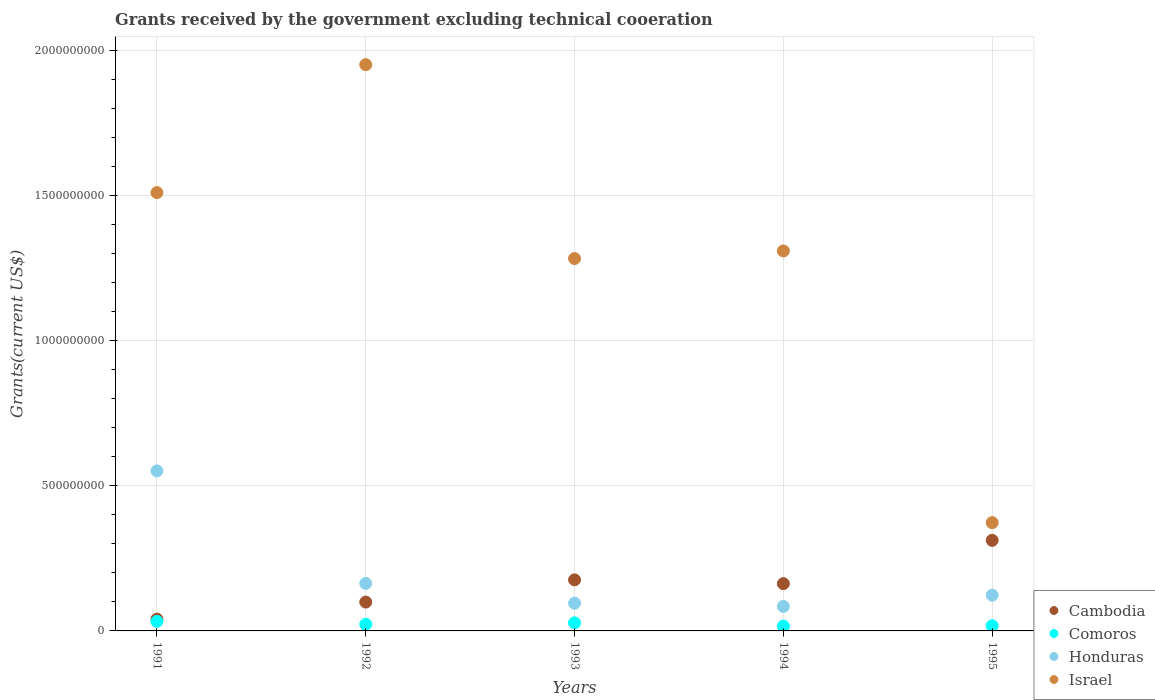How many different coloured dotlines are there?
Provide a succinct answer. 4. Is the number of dotlines equal to the number of legend labels?
Give a very brief answer. Yes. What is the total grants received by the government in Comoros in 1992?
Keep it short and to the point. 2.28e+07. Across all years, what is the maximum total grants received by the government in Honduras?
Keep it short and to the point. 5.52e+08. Across all years, what is the minimum total grants received by the government in Israel?
Keep it short and to the point. 3.73e+08. In which year was the total grants received by the government in Honduras minimum?
Offer a very short reply. 1994. What is the total total grants received by the government in Cambodia in the graph?
Give a very brief answer. 7.91e+08. What is the difference between the total grants received by the government in Honduras in 1992 and that in 1993?
Offer a terse response. 6.81e+07. What is the difference between the total grants received by the government in Cambodia in 1992 and the total grants received by the government in Honduras in 1995?
Offer a terse response. -2.38e+07. What is the average total grants received by the government in Israel per year?
Make the answer very short. 1.29e+09. In the year 1991, what is the difference between the total grants received by the government in Comoros and total grants received by the government in Cambodia?
Keep it short and to the point. -7.92e+06. In how many years, is the total grants received by the government in Cambodia greater than 1100000000 US$?
Offer a very short reply. 0. What is the ratio of the total grants received by the government in Comoros in 1991 to that in 1994?
Provide a succinct answer. 1.99. What is the difference between the highest and the second highest total grants received by the government in Honduras?
Your response must be concise. 3.88e+08. What is the difference between the highest and the lowest total grants received by the government in Cambodia?
Keep it short and to the point. 2.72e+08. Is it the case that in every year, the sum of the total grants received by the government in Honduras and total grants received by the government in Comoros  is greater than the total grants received by the government in Cambodia?
Give a very brief answer. No. Does the total grants received by the government in Israel monotonically increase over the years?
Ensure brevity in your answer.  No. Is the total grants received by the government in Honduras strictly greater than the total grants received by the government in Cambodia over the years?
Ensure brevity in your answer.  No. Is the total grants received by the government in Israel strictly less than the total grants received by the government in Honduras over the years?
Offer a terse response. No. How many dotlines are there?
Ensure brevity in your answer.  4. What is the difference between two consecutive major ticks on the Y-axis?
Your response must be concise. 5.00e+08. Where does the legend appear in the graph?
Give a very brief answer. Bottom right. How are the legend labels stacked?
Give a very brief answer. Vertical. What is the title of the graph?
Provide a short and direct response. Grants received by the government excluding technical cooeration. Does "Azerbaijan" appear as one of the legend labels in the graph?
Provide a succinct answer. No. What is the label or title of the X-axis?
Your answer should be very brief. Years. What is the label or title of the Y-axis?
Provide a succinct answer. Grants(current US$). What is the Grants(current US$) of Cambodia in 1991?
Make the answer very short. 4.07e+07. What is the Grants(current US$) in Comoros in 1991?
Provide a succinct answer. 3.28e+07. What is the Grants(current US$) in Honduras in 1991?
Your answer should be very brief. 5.52e+08. What is the Grants(current US$) in Israel in 1991?
Provide a short and direct response. 1.51e+09. What is the Grants(current US$) in Cambodia in 1992?
Ensure brevity in your answer.  9.94e+07. What is the Grants(current US$) of Comoros in 1992?
Your response must be concise. 2.28e+07. What is the Grants(current US$) of Honduras in 1992?
Your response must be concise. 1.64e+08. What is the Grants(current US$) of Israel in 1992?
Make the answer very short. 1.95e+09. What is the Grants(current US$) in Cambodia in 1993?
Your response must be concise. 1.76e+08. What is the Grants(current US$) in Comoros in 1993?
Provide a short and direct response. 2.78e+07. What is the Grants(current US$) of Honduras in 1993?
Make the answer very short. 9.57e+07. What is the Grants(current US$) in Israel in 1993?
Offer a very short reply. 1.28e+09. What is the Grants(current US$) of Cambodia in 1994?
Offer a terse response. 1.63e+08. What is the Grants(current US$) of Comoros in 1994?
Your answer should be very brief. 1.65e+07. What is the Grants(current US$) in Honduras in 1994?
Make the answer very short. 8.44e+07. What is the Grants(current US$) of Israel in 1994?
Your response must be concise. 1.31e+09. What is the Grants(current US$) in Cambodia in 1995?
Ensure brevity in your answer.  3.12e+08. What is the Grants(current US$) of Comoros in 1995?
Give a very brief answer. 1.78e+07. What is the Grants(current US$) of Honduras in 1995?
Offer a terse response. 1.23e+08. What is the Grants(current US$) in Israel in 1995?
Provide a succinct answer. 3.73e+08. Across all years, what is the maximum Grants(current US$) of Cambodia?
Make the answer very short. 3.12e+08. Across all years, what is the maximum Grants(current US$) in Comoros?
Offer a very short reply. 3.28e+07. Across all years, what is the maximum Grants(current US$) of Honduras?
Provide a succinct answer. 5.52e+08. Across all years, what is the maximum Grants(current US$) in Israel?
Keep it short and to the point. 1.95e+09. Across all years, what is the minimum Grants(current US$) of Cambodia?
Your response must be concise. 4.07e+07. Across all years, what is the minimum Grants(current US$) of Comoros?
Provide a succinct answer. 1.65e+07. Across all years, what is the minimum Grants(current US$) of Honduras?
Make the answer very short. 8.44e+07. Across all years, what is the minimum Grants(current US$) in Israel?
Ensure brevity in your answer.  3.73e+08. What is the total Grants(current US$) of Cambodia in the graph?
Ensure brevity in your answer.  7.91e+08. What is the total Grants(current US$) in Comoros in the graph?
Your response must be concise. 1.18e+08. What is the total Grants(current US$) of Honduras in the graph?
Keep it short and to the point. 1.02e+09. What is the total Grants(current US$) of Israel in the graph?
Provide a succinct answer. 6.43e+09. What is the difference between the Grants(current US$) of Cambodia in 1991 and that in 1992?
Ensure brevity in your answer.  -5.87e+07. What is the difference between the Grants(current US$) in Comoros in 1991 and that in 1992?
Your answer should be very brief. 9.98e+06. What is the difference between the Grants(current US$) in Honduras in 1991 and that in 1992?
Give a very brief answer. 3.88e+08. What is the difference between the Grants(current US$) in Israel in 1991 and that in 1992?
Your answer should be compact. -4.41e+08. What is the difference between the Grants(current US$) of Cambodia in 1991 and that in 1993?
Your answer should be compact. -1.35e+08. What is the difference between the Grants(current US$) in Comoros in 1991 and that in 1993?
Your answer should be very brief. 4.96e+06. What is the difference between the Grants(current US$) in Honduras in 1991 and that in 1993?
Make the answer very short. 4.56e+08. What is the difference between the Grants(current US$) in Israel in 1991 and that in 1993?
Your answer should be very brief. 2.27e+08. What is the difference between the Grants(current US$) in Cambodia in 1991 and that in 1994?
Your response must be concise. -1.22e+08. What is the difference between the Grants(current US$) in Comoros in 1991 and that in 1994?
Offer a terse response. 1.63e+07. What is the difference between the Grants(current US$) of Honduras in 1991 and that in 1994?
Ensure brevity in your answer.  4.67e+08. What is the difference between the Grants(current US$) of Israel in 1991 and that in 1994?
Your answer should be very brief. 2.01e+08. What is the difference between the Grants(current US$) of Cambodia in 1991 and that in 1995?
Keep it short and to the point. -2.72e+08. What is the difference between the Grants(current US$) of Comoros in 1991 and that in 1995?
Offer a terse response. 1.50e+07. What is the difference between the Grants(current US$) of Honduras in 1991 and that in 1995?
Make the answer very short. 4.28e+08. What is the difference between the Grants(current US$) of Israel in 1991 and that in 1995?
Give a very brief answer. 1.14e+09. What is the difference between the Grants(current US$) in Cambodia in 1992 and that in 1993?
Your response must be concise. -7.66e+07. What is the difference between the Grants(current US$) in Comoros in 1992 and that in 1993?
Provide a succinct answer. -5.02e+06. What is the difference between the Grants(current US$) of Honduras in 1992 and that in 1993?
Your answer should be compact. 6.81e+07. What is the difference between the Grants(current US$) in Israel in 1992 and that in 1993?
Ensure brevity in your answer.  6.68e+08. What is the difference between the Grants(current US$) of Cambodia in 1992 and that in 1994?
Your answer should be compact. -6.36e+07. What is the difference between the Grants(current US$) of Comoros in 1992 and that in 1994?
Keep it short and to the point. 6.30e+06. What is the difference between the Grants(current US$) in Honduras in 1992 and that in 1994?
Provide a short and direct response. 7.93e+07. What is the difference between the Grants(current US$) in Israel in 1992 and that in 1994?
Your answer should be compact. 6.42e+08. What is the difference between the Grants(current US$) of Cambodia in 1992 and that in 1995?
Offer a terse response. -2.13e+08. What is the difference between the Grants(current US$) in Comoros in 1992 and that in 1995?
Offer a very short reply. 5.06e+06. What is the difference between the Grants(current US$) of Honduras in 1992 and that in 1995?
Provide a short and direct response. 4.06e+07. What is the difference between the Grants(current US$) in Israel in 1992 and that in 1995?
Keep it short and to the point. 1.58e+09. What is the difference between the Grants(current US$) in Cambodia in 1993 and that in 1994?
Give a very brief answer. 1.30e+07. What is the difference between the Grants(current US$) of Comoros in 1993 and that in 1994?
Provide a short and direct response. 1.13e+07. What is the difference between the Grants(current US$) in Honduras in 1993 and that in 1994?
Your answer should be compact. 1.12e+07. What is the difference between the Grants(current US$) of Israel in 1993 and that in 1994?
Offer a very short reply. -2.63e+07. What is the difference between the Grants(current US$) of Cambodia in 1993 and that in 1995?
Ensure brevity in your answer.  -1.36e+08. What is the difference between the Grants(current US$) of Comoros in 1993 and that in 1995?
Keep it short and to the point. 1.01e+07. What is the difference between the Grants(current US$) of Honduras in 1993 and that in 1995?
Ensure brevity in your answer.  -2.75e+07. What is the difference between the Grants(current US$) in Israel in 1993 and that in 1995?
Give a very brief answer. 9.10e+08. What is the difference between the Grants(current US$) of Cambodia in 1994 and that in 1995?
Your answer should be compact. -1.49e+08. What is the difference between the Grants(current US$) of Comoros in 1994 and that in 1995?
Your answer should be compact. -1.24e+06. What is the difference between the Grants(current US$) of Honduras in 1994 and that in 1995?
Keep it short and to the point. -3.88e+07. What is the difference between the Grants(current US$) of Israel in 1994 and that in 1995?
Your answer should be compact. 9.37e+08. What is the difference between the Grants(current US$) in Cambodia in 1991 and the Grants(current US$) in Comoros in 1992?
Your response must be concise. 1.79e+07. What is the difference between the Grants(current US$) of Cambodia in 1991 and the Grants(current US$) of Honduras in 1992?
Give a very brief answer. -1.23e+08. What is the difference between the Grants(current US$) of Cambodia in 1991 and the Grants(current US$) of Israel in 1992?
Provide a succinct answer. -1.91e+09. What is the difference between the Grants(current US$) in Comoros in 1991 and the Grants(current US$) in Honduras in 1992?
Your answer should be very brief. -1.31e+08. What is the difference between the Grants(current US$) of Comoros in 1991 and the Grants(current US$) of Israel in 1992?
Your answer should be compact. -1.92e+09. What is the difference between the Grants(current US$) of Honduras in 1991 and the Grants(current US$) of Israel in 1992?
Your response must be concise. -1.40e+09. What is the difference between the Grants(current US$) in Cambodia in 1991 and the Grants(current US$) in Comoros in 1993?
Provide a succinct answer. 1.29e+07. What is the difference between the Grants(current US$) in Cambodia in 1991 and the Grants(current US$) in Honduras in 1993?
Make the answer very short. -5.50e+07. What is the difference between the Grants(current US$) of Cambodia in 1991 and the Grants(current US$) of Israel in 1993?
Ensure brevity in your answer.  -1.24e+09. What is the difference between the Grants(current US$) in Comoros in 1991 and the Grants(current US$) in Honduras in 1993?
Your response must be concise. -6.29e+07. What is the difference between the Grants(current US$) in Comoros in 1991 and the Grants(current US$) in Israel in 1993?
Your answer should be very brief. -1.25e+09. What is the difference between the Grants(current US$) in Honduras in 1991 and the Grants(current US$) in Israel in 1993?
Give a very brief answer. -7.32e+08. What is the difference between the Grants(current US$) of Cambodia in 1991 and the Grants(current US$) of Comoros in 1994?
Your response must be concise. 2.42e+07. What is the difference between the Grants(current US$) of Cambodia in 1991 and the Grants(current US$) of Honduras in 1994?
Your response must be concise. -4.37e+07. What is the difference between the Grants(current US$) in Cambodia in 1991 and the Grants(current US$) in Israel in 1994?
Make the answer very short. -1.27e+09. What is the difference between the Grants(current US$) in Comoros in 1991 and the Grants(current US$) in Honduras in 1994?
Offer a terse response. -5.16e+07. What is the difference between the Grants(current US$) of Comoros in 1991 and the Grants(current US$) of Israel in 1994?
Give a very brief answer. -1.28e+09. What is the difference between the Grants(current US$) in Honduras in 1991 and the Grants(current US$) in Israel in 1994?
Give a very brief answer. -7.58e+08. What is the difference between the Grants(current US$) in Cambodia in 1991 and the Grants(current US$) in Comoros in 1995?
Give a very brief answer. 2.30e+07. What is the difference between the Grants(current US$) in Cambodia in 1991 and the Grants(current US$) in Honduras in 1995?
Ensure brevity in your answer.  -8.25e+07. What is the difference between the Grants(current US$) in Cambodia in 1991 and the Grants(current US$) in Israel in 1995?
Provide a short and direct response. -3.33e+08. What is the difference between the Grants(current US$) of Comoros in 1991 and the Grants(current US$) of Honduras in 1995?
Keep it short and to the point. -9.04e+07. What is the difference between the Grants(current US$) of Comoros in 1991 and the Grants(current US$) of Israel in 1995?
Your answer should be very brief. -3.41e+08. What is the difference between the Grants(current US$) in Honduras in 1991 and the Grants(current US$) in Israel in 1995?
Make the answer very short. 1.78e+08. What is the difference between the Grants(current US$) of Cambodia in 1992 and the Grants(current US$) of Comoros in 1993?
Your answer should be very brief. 7.16e+07. What is the difference between the Grants(current US$) in Cambodia in 1992 and the Grants(current US$) in Honduras in 1993?
Your answer should be very brief. 3.73e+06. What is the difference between the Grants(current US$) of Cambodia in 1992 and the Grants(current US$) of Israel in 1993?
Your answer should be very brief. -1.18e+09. What is the difference between the Grants(current US$) in Comoros in 1992 and the Grants(current US$) in Honduras in 1993?
Offer a very short reply. -7.29e+07. What is the difference between the Grants(current US$) of Comoros in 1992 and the Grants(current US$) of Israel in 1993?
Provide a short and direct response. -1.26e+09. What is the difference between the Grants(current US$) in Honduras in 1992 and the Grants(current US$) in Israel in 1993?
Your response must be concise. -1.12e+09. What is the difference between the Grants(current US$) of Cambodia in 1992 and the Grants(current US$) of Comoros in 1994?
Your answer should be very brief. 8.29e+07. What is the difference between the Grants(current US$) of Cambodia in 1992 and the Grants(current US$) of Honduras in 1994?
Make the answer very short. 1.50e+07. What is the difference between the Grants(current US$) in Cambodia in 1992 and the Grants(current US$) in Israel in 1994?
Ensure brevity in your answer.  -1.21e+09. What is the difference between the Grants(current US$) of Comoros in 1992 and the Grants(current US$) of Honduras in 1994?
Offer a terse response. -6.16e+07. What is the difference between the Grants(current US$) in Comoros in 1992 and the Grants(current US$) in Israel in 1994?
Your answer should be very brief. -1.29e+09. What is the difference between the Grants(current US$) of Honduras in 1992 and the Grants(current US$) of Israel in 1994?
Ensure brevity in your answer.  -1.15e+09. What is the difference between the Grants(current US$) in Cambodia in 1992 and the Grants(current US$) in Comoros in 1995?
Give a very brief answer. 8.17e+07. What is the difference between the Grants(current US$) in Cambodia in 1992 and the Grants(current US$) in Honduras in 1995?
Offer a very short reply. -2.38e+07. What is the difference between the Grants(current US$) in Cambodia in 1992 and the Grants(current US$) in Israel in 1995?
Your answer should be compact. -2.74e+08. What is the difference between the Grants(current US$) of Comoros in 1992 and the Grants(current US$) of Honduras in 1995?
Keep it short and to the point. -1.00e+08. What is the difference between the Grants(current US$) of Comoros in 1992 and the Grants(current US$) of Israel in 1995?
Provide a succinct answer. -3.51e+08. What is the difference between the Grants(current US$) in Honduras in 1992 and the Grants(current US$) in Israel in 1995?
Provide a succinct answer. -2.10e+08. What is the difference between the Grants(current US$) of Cambodia in 1993 and the Grants(current US$) of Comoros in 1994?
Offer a very short reply. 1.60e+08. What is the difference between the Grants(current US$) of Cambodia in 1993 and the Grants(current US$) of Honduras in 1994?
Provide a short and direct response. 9.16e+07. What is the difference between the Grants(current US$) in Cambodia in 1993 and the Grants(current US$) in Israel in 1994?
Provide a short and direct response. -1.13e+09. What is the difference between the Grants(current US$) of Comoros in 1993 and the Grants(current US$) of Honduras in 1994?
Your answer should be compact. -5.66e+07. What is the difference between the Grants(current US$) in Comoros in 1993 and the Grants(current US$) in Israel in 1994?
Ensure brevity in your answer.  -1.28e+09. What is the difference between the Grants(current US$) of Honduras in 1993 and the Grants(current US$) of Israel in 1994?
Offer a very short reply. -1.21e+09. What is the difference between the Grants(current US$) of Cambodia in 1993 and the Grants(current US$) of Comoros in 1995?
Your answer should be compact. 1.58e+08. What is the difference between the Grants(current US$) in Cambodia in 1993 and the Grants(current US$) in Honduras in 1995?
Make the answer very short. 5.28e+07. What is the difference between the Grants(current US$) of Cambodia in 1993 and the Grants(current US$) of Israel in 1995?
Your response must be concise. -1.97e+08. What is the difference between the Grants(current US$) of Comoros in 1993 and the Grants(current US$) of Honduras in 1995?
Provide a short and direct response. -9.54e+07. What is the difference between the Grants(current US$) of Comoros in 1993 and the Grants(current US$) of Israel in 1995?
Provide a succinct answer. -3.46e+08. What is the difference between the Grants(current US$) in Honduras in 1993 and the Grants(current US$) in Israel in 1995?
Your answer should be very brief. -2.78e+08. What is the difference between the Grants(current US$) of Cambodia in 1994 and the Grants(current US$) of Comoros in 1995?
Your answer should be compact. 1.45e+08. What is the difference between the Grants(current US$) of Cambodia in 1994 and the Grants(current US$) of Honduras in 1995?
Provide a succinct answer. 3.98e+07. What is the difference between the Grants(current US$) in Cambodia in 1994 and the Grants(current US$) in Israel in 1995?
Your answer should be compact. -2.10e+08. What is the difference between the Grants(current US$) in Comoros in 1994 and the Grants(current US$) in Honduras in 1995?
Your answer should be very brief. -1.07e+08. What is the difference between the Grants(current US$) in Comoros in 1994 and the Grants(current US$) in Israel in 1995?
Your answer should be compact. -3.57e+08. What is the difference between the Grants(current US$) of Honduras in 1994 and the Grants(current US$) of Israel in 1995?
Make the answer very short. -2.89e+08. What is the average Grants(current US$) of Cambodia per year?
Provide a succinct answer. 1.58e+08. What is the average Grants(current US$) of Comoros per year?
Your response must be concise. 2.35e+07. What is the average Grants(current US$) of Honduras per year?
Keep it short and to the point. 2.04e+08. What is the average Grants(current US$) in Israel per year?
Your answer should be very brief. 1.29e+09. In the year 1991, what is the difference between the Grants(current US$) in Cambodia and Grants(current US$) in Comoros?
Your answer should be very brief. 7.92e+06. In the year 1991, what is the difference between the Grants(current US$) in Cambodia and Grants(current US$) in Honduras?
Your answer should be compact. -5.11e+08. In the year 1991, what is the difference between the Grants(current US$) of Cambodia and Grants(current US$) of Israel?
Offer a terse response. -1.47e+09. In the year 1991, what is the difference between the Grants(current US$) of Comoros and Grants(current US$) of Honduras?
Make the answer very short. -5.19e+08. In the year 1991, what is the difference between the Grants(current US$) in Comoros and Grants(current US$) in Israel?
Provide a succinct answer. -1.48e+09. In the year 1991, what is the difference between the Grants(current US$) in Honduras and Grants(current US$) in Israel?
Provide a short and direct response. -9.60e+08. In the year 1992, what is the difference between the Grants(current US$) in Cambodia and Grants(current US$) in Comoros?
Provide a short and direct response. 7.66e+07. In the year 1992, what is the difference between the Grants(current US$) in Cambodia and Grants(current US$) in Honduras?
Your answer should be very brief. -6.43e+07. In the year 1992, what is the difference between the Grants(current US$) in Cambodia and Grants(current US$) in Israel?
Make the answer very short. -1.85e+09. In the year 1992, what is the difference between the Grants(current US$) in Comoros and Grants(current US$) in Honduras?
Provide a succinct answer. -1.41e+08. In the year 1992, what is the difference between the Grants(current US$) in Comoros and Grants(current US$) in Israel?
Make the answer very short. -1.93e+09. In the year 1992, what is the difference between the Grants(current US$) in Honduras and Grants(current US$) in Israel?
Your response must be concise. -1.79e+09. In the year 1993, what is the difference between the Grants(current US$) of Cambodia and Grants(current US$) of Comoros?
Your response must be concise. 1.48e+08. In the year 1993, what is the difference between the Grants(current US$) in Cambodia and Grants(current US$) in Honduras?
Keep it short and to the point. 8.03e+07. In the year 1993, what is the difference between the Grants(current US$) in Cambodia and Grants(current US$) in Israel?
Your response must be concise. -1.11e+09. In the year 1993, what is the difference between the Grants(current US$) of Comoros and Grants(current US$) of Honduras?
Keep it short and to the point. -6.78e+07. In the year 1993, what is the difference between the Grants(current US$) in Comoros and Grants(current US$) in Israel?
Offer a very short reply. -1.26e+09. In the year 1993, what is the difference between the Grants(current US$) in Honduras and Grants(current US$) in Israel?
Your answer should be very brief. -1.19e+09. In the year 1994, what is the difference between the Grants(current US$) of Cambodia and Grants(current US$) of Comoros?
Your answer should be very brief. 1.46e+08. In the year 1994, what is the difference between the Grants(current US$) in Cambodia and Grants(current US$) in Honduras?
Provide a succinct answer. 7.86e+07. In the year 1994, what is the difference between the Grants(current US$) of Cambodia and Grants(current US$) of Israel?
Offer a terse response. -1.15e+09. In the year 1994, what is the difference between the Grants(current US$) in Comoros and Grants(current US$) in Honduras?
Provide a short and direct response. -6.79e+07. In the year 1994, what is the difference between the Grants(current US$) of Comoros and Grants(current US$) of Israel?
Provide a succinct answer. -1.29e+09. In the year 1994, what is the difference between the Grants(current US$) in Honduras and Grants(current US$) in Israel?
Keep it short and to the point. -1.23e+09. In the year 1995, what is the difference between the Grants(current US$) in Cambodia and Grants(current US$) in Comoros?
Your answer should be very brief. 2.94e+08. In the year 1995, what is the difference between the Grants(current US$) in Cambodia and Grants(current US$) in Honduras?
Make the answer very short. 1.89e+08. In the year 1995, what is the difference between the Grants(current US$) of Cambodia and Grants(current US$) of Israel?
Give a very brief answer. -6.11e+07. In the year 1995, what is the difference between the Grants(current US$) in Comoros and Grants(current US$) in Honduras?
Ensure brevity in your answer.  -1.05e+08. In the year 1995, what is the difference between the Grants(current US$) in Comoros and Grants(current US$) in Israel?
Your answer should be compact. -3.56e+08. In the year 1995, what is the difference between the Grants(current US$) in Honduras and Grants(current US$) in Israel?
Offer a very short reply. -2.50e+08. What is the ratio of the Grants(current US$) of Cambodia in 1991 to that in 1992?
Offer a very short reply. 0.41. What is the ratio of the Grants(current US$) in Comoros in 1991 to that in 1992?
Ensure brevity in your answer.  1.44. What is the ratio of the Grants(current US$) of Honduras in 1991 to that in 1992?
Keep it short and to the point. 3.37. What is the ratio of the Grants(current US$) of Israel in 1991 to that in 1992?
Give a very brief answer. 0.77. What is the ratio of the Grants(current US$) in Cambodia in 1991 to that in 1993?
Your response must be concise. 0.23. What is the ratio of the Grants(current US$) of Comoros in 1991 to that in 1993?
Ensure brevity in your answer.  1.18. What is the ratio of the Grants(current US$) of Honduras in 1991 to that in 1993?
Your answer should be very brief. 5.77. What is the ratio of the Grants(current US$) in Israel in 1991 to that in 1993?
Offer a very short reply. 1.18. What is the ratio of the Grants(current US$) of Cambodia in 1991 to that in 1994?
Make the answer very short. 0.25. What is the ratio of the Grants(current US$) of Comoros in 1991 to that in 1994?
Provide a short and direct response. 1.99. What is the ratio of the Grants(current US$) of Honduras in 1991 to that in 1994?
Your answer should be very brief. 6.53. What is the ratio of the Grants(current US$) of Israel in 1991 to that in 1994?
Offer a very short reply. 1.15. What is the ratio of the Grants(current US$) in Cambodia in 1991 to that in 1995?
Your answer should be compact. 0.13. What is the ratio of the Grants(current US$) of Comoros in 1991 to that in 1995?
Your answer should be very brief. 1.85. What is the ratio of the Grants(current US$) of Honduras in 1991 to that in 1995?
Your answer should be compact. 4.48. What is the ratio of the Grants(current US$) in Israel in 1991 to that in 1995?
Provide a succinct answer. 4.05. What is the ratio of the Grants(current US$) of Cambodia in 1992 to that in 1993?
Ensure brevity in your answer.  0.56. What is the ratio of the Grants(current US$) of Comoros in 1992 to that in 1993?
Offer a very short reply. 0.82. What is the ratio of the Grants(current US$) of Honduras in 1992 to that in 1993?
Give a very brief answer. 1.71. What is the ratio of the Grants(current US$) in Israel in 1992 to that in 1993?
Keep it short and to the point. 1.52. What is the ratio of the Grants(current US$) of Cambodia in 1992 to that in 1994?
Your response must be concise. 0.61. What is the ratio of the Grants(current US$) of Comoros in 1992 to that in 1994?
Make the answer very short. 1.38. What is the ratio of the Grants(current US$) in Honduras in 1992 to that in 1994?
Offer a very short reply. 1.94. What is the ratio of the Grants(current US$) in Israel in 1992 to that in 1994?
Your response must be concise. 1.49. What is the ratio of the Grants(current US$) in Cambodia in 1992 to that in 1995?
Your answer should be compact. 0.32. What is the ratio of the Grants(current US$) in Comoros in 1992 to that in 1995?
Your response must be concise. 1.29. What is the ratio of the Grants(current US$) in Honduras in 1992 to that in 1995?
Provide a short and direct response. 1.33. What is the ratio of the Grants(current US$) in Israel in 1992 to that in 1995?
Ensure brevity in your answer.  5.23. What is the ratio of the Grants(current US$) in Cambodia in 1993 to that in 1994?
Your answer should be compact. 1.08. What is the ratio of the Grants(current US$) in Comoros in 1993 to that in 1994?
Your answer should be very brief. 1.69. What is the ratio of the Grants(current US$) in Honduras in 1993 to that in 1994?
Give a very brief answer. 1.13. What is the ratio of the Grants(current US$) of Israel in 1993 to that in 1994?
Offer a very short reply. 0.98. What is the ratio of the Grants(current US$) of Cambodia in 1993 to that in 1995?
Ensure brevity in your answer.  0.56. What is the ratio of the Grants(current US$) of Comoros in 1993 to that in 1995?
Your answer should be compact. 1.57. What is the ratio of the Grants(current US$) in Honduras in 1993 to that in 1995?
Give a very brief answer. 0.78. What is the ratio of the Grants(current US$) in Israel in 1993 to that in 1995?
Your response must be concise. 3.44. What is the ratio of the Grants(current US$) in Cambodia in 1994 to that in 1995?
Offer a terse response. 0.52. What is the ratio of the Grants(current US$) in Comoros in 1994 to that in 1995?
Offer a terse response. 0.93. What is the ratio of the Grants(current US$) in Honduras in 1994 to that in 1995?
Provide a succinct answer. 0.69. What is the ratio of the Grants(current US$) in Israel in 1994 to that in 1995?
Your answer should be very brief. 3.51. What is the difference between the highest and the second highest Grants(current US$) of Cambodia?
Ensure brevity in your answer.  1.36e+08. What is the difference between the highest and the second highest Grants(current US$) in Comoros?
Your response must be concise. 4.96e+06. What is the difference between the highest and the second highest Grants(current US$) of Honduras?
Give a very brief answer. 3.88e+08. What is the difference between the highest and the second highest Grants(current US$) of Israel?
Offer a terse response. 4.41e+08. What is the difference between the highest and the lowest Grants(current US$) of Cambodia?
Keep it short and to the point. 2.72e+08. What is the difference between the highest and the lowest Grants(current US$) in Comoros?
Your answer should be compact. 1.63e+07. What is the difference between the highest and the lowest Grants(current US$) of Honduras?
Your answer should be very brief. 4.67e+08. What is the difference between the highest and the lowest Grants(current US$) in Israel?
Your response must be concise. 1.58e+09. 